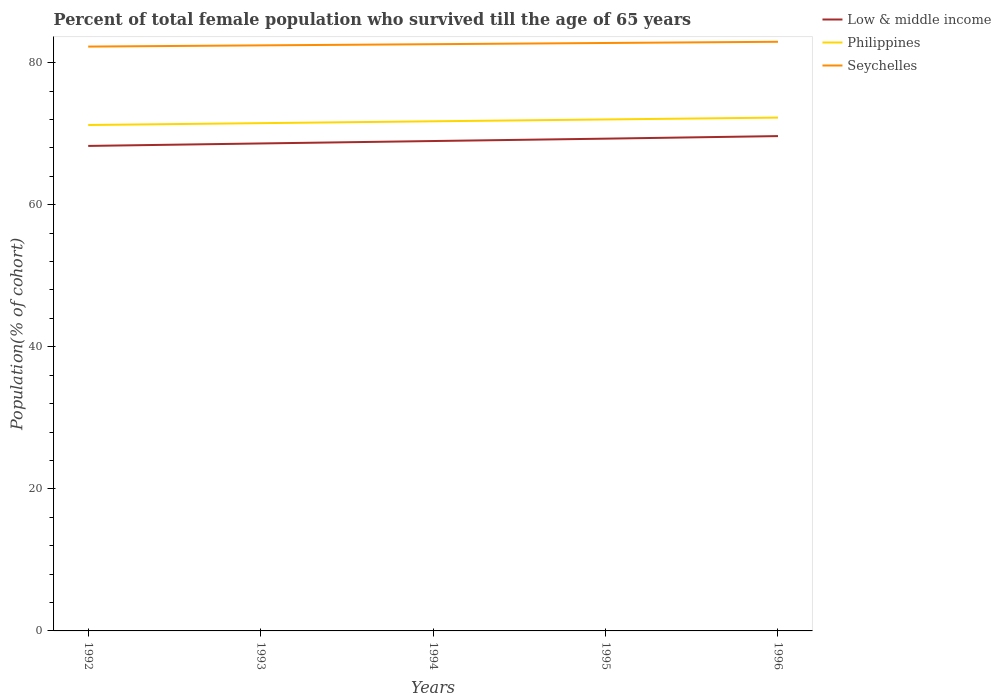Is the number of lines equal to the number of legend labels?
Offer a very short reply. Yes. Across all years, what is the maximum percentage of total female population who survived till the age of 65 years in Low & middle income?
Your answer should be compact. 68.28. What is the total percentage of total female population who survived till the age of 65 years in Low & middle income in the graph?
Your response must be concise. -0.36. What is the difference between the highest and the second highest percentage of total female population who survived till the age of 65 years in Low & middle income?
Ensure brevity in your answer.  1.38. Is the percentage of total female population who survived till the age of 65 years in Philippines strictly greater than the percentage of total female population who survived till the age of 65 years in Seychelles over the years?
Offer a very short reply. Yes. How many lines are there?
Keep it short and to the point. 3. How many years are there in the graph?
Offer a very short reply. 5. What is the difference between two consecutive major ticks on the Y-axis?
Offer a very short reply. 20. Are the values on the major ticks of Y-axis written in scientific E-notation?
Provide a short and direct response. No. Does the graph contain any zero values?
Your answer should be compact. No. Does the graph contain grids?
Provide a succinct answer. No. How many legend labels are there?
Your answer should be very brief. 3. What is the title of the graph?
Ensure brevity in your answer.  Percent of total female population who survived till the age of 65 years. What is the label or title of the Y-axis?
Your answer should be very brief. Population(% of cohort). What is the Population(% of cohort) of Low & middle income in 1992?
Your response must be concise. 68.28. What is the Population(% of cohort) in Philippines in 1992?
Offer a terse response. 71.23. What is the Population(% of cohort) in Seychelles in 1992?
Make the answer very short. 82.27. What is the Population(% of cohort) in Low & middle income in 1993?
Provide a succinct answer. 68.63. What is the Population(% of cohort) in Philippines in 1993?
Keep it short and to the point. 71.49. What is the Population(% of cohort) in Seychelles in 1993?
Your answer should be compact. 82.44. What is the Population(% of cohort) of Low & middle income in 1994?
Provide a succinct answer. 68.97. What is the Population(% of cohort) in Philippines in 1994?
Provide a short and direct response. 71.75. What is the Population(% of cohort) of Seychelles in 1994?
Your answer should be very brief. 82.6. What is the Population(% of cohort) in Low & middle income in 1995?
Provide a short and direct response. 69.3. What is the Population(% of cohort) in Philippines in 1995?
Keep it short and to the point. 72.01. What is the Population(% of cohort) of Seychelles in 1995?
Your response must be concise. 82.77. What is the Population(% of cohort) in Low & middle income in 1996?
Give a very brief answer. 69.66. What is the Population(% of cohort) of Philippines in 1996?
Provide a succinct answer. 72.27. What is the Population(% of cohort) of Seychelles in 1996?
Keep it short and to the point. 82.94. Across all years, what is the maximum Population(% of cohort) of Low & middle income?
Your response must be concise. 69.66. Across all years, what is the maximum Population(% of cohort) of Philippines?
Your answer should be very brief. 72.27. Across all years, what is the maximum Population(% of cohort) in Seychelles?
Offer a terse response. 82.94. Across all years, what is the minimum Population(% of cohort) in Low & middle income?
Your answer should be compact. 68.28. Across all years, what is the minimum Population(% of cohort) in Philippines?
Keep it short and to the point. 71.23. Across all years, what is the minimum Population(% of cohort) of Seychelles?
Offer a very short reply. 82.27. What is the total Population(% of cohort) in Low & middle income in the graph?
Your response must be concise. 344.84. What is the total Population(% of cohort) in Philippines in the graph?
Your answer should be compact. 358.73. What is the total Population(% of cohort) in Seychelles in the graph?
Your answer should be very brief. 413.02. What is the difference between the Population(% of cohort) of Low & middle income in 1992 and that in 1993?
Provide a succinct answer. -0.35. What is the difference between the Population(% of cohort) of Philippines in 1992 and that in 1993?
Give a very brief answer. -0.26. What is the difference between the Population(% of cohort) of Seychelles in 1992 and that in 1993?
Make the answer very short. -0.17. What is the difference between the Population(% of cohort) of Low & middle income in 1992 and that in 1994?
Provide a succinct answer. -0.69. What is the difference between the Population(% of cohort) in Philippines in 1992 and that in 1994?
Offer a terse response. -0.52. What is the difference between the Population(% of cohort) of Seychelles in 1992 and that in 1994?
Your response must be concise. -0.34. What is the difference between the Population(% of cohort) of Low & middle income in 1992 and that in 1995?
Your answer should be compact. -1.02. What is the difference between the Population(% of cohort) in Philippines in 1992 and that in 1995?
Offer a very short reply. -0.78. What is the difference between the Population(% of cohort) of Seychelles in 1992 and that in 1995?
Provide a succinct answer. -0.51. What is the difference between the Population(% of cohort) of Low & middle income in 1992 and that in 1996?
Your answer should be very brief. -1.38. What is the difference between the Population(% of cohort) in Philippines in 1992 and that in 1996?
Your answer should be very brief. -1.04. What is the difference between the Population(% of cohort) in Seychelles in 1992 and that in 1996?
Provide a succinct answer. -0.68. What is the difference between the Population(% of cohort) of Low & middle income in 1993 and that in 1994?
Keep it short and to the point. -0.34. What is the difference between the Population(% of cohort) in Philippines in 1993 and that in 1994?
Provide a short and direct response. -0.26. What is the difference between the Population(% of cohort) in Seychelles in 1993 and that in 1994?
Your response must be concise. -0.17. What is the difference between the Population(% of cohort) of Low & middle income in 1993 and that in 1995?
Offer a very short reply. -0.68. What is the difference between the Population(% of cohort) in Philippines in 1993 and that in 1995?
Give a very brief answer. -0.52. What is the difference between the Population(% of cohort) in Seychelles in 1993 and that in 1995?
Provide a succinct answer. -0.34. What is the difference between the Population(% of cohort) in Low & middle income in 1993 and that in 1996?
Your answer should be compact. -1.04. What is the difference between the Population(% of cohort) in Philippines in 1993 and that in 1996?
Your answer should be compact. -0.78. What is the difference between the Population(% of cohort) of Seychelles in 1993 and that in 1996?
Your response must be concise. -0.51. What is the difference between the Population(% of cohort) in Low & middle income in 1994 and that in 1995?
Offer a terse response. -0.33. What is the difference between the Population(% of cohort) of Philippines in 1994 and that in 1995?
Keep it short and to the point. -0.26. What is the difference between the Population(% of cohort) in Seychelles in 1994 and that in 1995?
Your answer should be very brief. -0.17. What is the difference between the Population(% of cohort) in Low & middle income in 1994 and that in 1996?
Offer a terse response. -0.7. What is the difference between the Population(% of cohort) in Philippines in 1994 and that in 1996?
Provide a succinct answer. -0.52. What is the difference between the Population(% of cohort) of Seychelles in 1994 and that in 1996?
Keep it short and to the point. -0.34. What is the difference between the Population(% of cohort) of Low & middle income in 1995 and that in 1996?
Offer a very short reply. -0.36. What is the difference between the Population(% of cohort) in Philippines in 1995 and that in 1996?
Make the answer very short. -0.26. What is the difference between the Population(% of cohort) of Seychelles in 1995 and that in 1996?
Your answer should be very brief. -0.17. What is the difference between the Population(% of cohort) in Low & middle income in 1992 and the Population(% of cohort) in Philippines in 1993?
Give a very brief answer. -3.21. What is the difference between the Population(% of cohort) in Low & middle income in 1992 and the Population(% of cohort) in Seychelles in 1993?
Provide a succinct answer. -14.15. What is the difference between the Population(% of cohort) in Philippines in 1992 and the Population(% of cohort) in Seychelles in 1993?
Provide a succinct answer. -11.21. What is the difference between the Population(% of cohort) of Low & middle income in 1992 and the Population(% of cohort) of Philippines in 1994?
Your answer should be very brief. -3.47. What is the difference between the Population(% of cohort) of Low & middle income in 1992 and the Population(% of cohort) of Seychelles in 1994?
Provide a short and direct response. -14.32. What is the difference between the Population(% of cohort) in Philippines in 1992 and the Population(% of cohort) in Seychelles in 1994?
Keep it short and to the point. -11.38. What is the difference between the Population(% of cohort) of Low & middle income in 1992 and the Population(% of cohort) of Philippines in 1995?
Give a very brief answer. -3.73. What is the difference between the Population(% of cohort) of Low & middle income in 1992 and the Population(% of cohort) of Seychelles in 1995?
Keep it short and to the point. -14.49. What is the difference between the Population(% of cohort) in Philippines in 1992 and the Population(% of cohort) in Seychelles in 1995?
Your response must be concise. -11.55. What is the difference between the Population(% of cohort) in Low & middle income in 1992 and the Population(% of cohort) in Philippines in 1996?
Offer a very short reply. -3.99. What is the difference between the Population(% of cohort) in Low & middle income in 1992 and the Population(% of cohort) in Seychelles in 1996?
Ensure brevity in your answer.  -14.66. What is the difference between the Population(% of cohort) of Philippines in 1992 and the Population(% of cohort) of Seychelles in 1996?
Ensure brevity in your answer.  -11.72. What is the difference between the Population(% of cohort) in Low & middle income in 1993 and the Population(% of cohort) in Philippines in 1994?
Provide a short and direct response. -3.12. What is the difference between the Population(% of cohort) of Low & middle income in 1993 and the Population(% of cohort) of Seychelles in 1994?
Offer a very short reply. -13.98. What is the difference between the Population(% of cohort) of Philippines in 1993 and the Population(% of cohort) of Seychelles in 1994?
Your answer should be compact. -11.12. What is the difference between the Population(% of cohort) of Low & middle income in 1993 and the Population(% of cohort) of Philippines in 1995?
Provide a succinct answer. -3.38. What is the difference between the Population(% of cohort) in Low & middle income in 1993 and the Population(% of cohort) in Seychelles in 1995?
Your answer should be very brief. -14.15. What is the difference between the Population(% of cohort) of Philippines in 1993 and the Population(% of cohort) of Seychelles in 1995?
Your answer should be compact. -11.29. What is the difference between the Population(% of cohort) of Low & middle income in 1993 and the Population(% of cohort) of Philippines in 1996?
Provide a short and direct response. -3.64. What is the difference between the Population(% of cohort) of Low & middle income in 1993 and the Population(% of cohort) of Seychelles in 1996?
Make the answer very short. -14.31. What is the difference between the Population(% of cohort) of Philippines in 1993 and the Population(% of cohort) of Seychelles in 1996?
Offer a very short reply. -11.46. What is the difference between the Population(% of cohort) in Low & middle income in 1994 and the Population(% of cohort) in Philippines in 1995?
Your answer should be very brief. -3.04. What is the difference between the Population(% of cohort) of Low & middle income in 1994 and the Population(% of cohort) of Seychelles in 1995?
Provide a succinct answer. -13.8. What is the difference between the Population(% of cohort) of Philippines in 1994 and the Population(% of cohort) of Seychelles in 1995?
Make the answer very short. -11.03. What is the difference between the Population(% of cohort) of Low & middle income in 1994 and the Population(% of cohort) of Philippines in 1996?
Offer a very short reply. -3.3. What is the difference between the Population(% of cohort) of Low & middle income in 1994 and the Population(% of cohort) of Seychelles in 1996?
Your answer should be very brief. -13.97. What is the difference between the Population(% of cohort) in Philippines in 1994 and the Population(% of cohort) in Seychelles in 1996?
Keep it short and to the point. -11.2. What is the difference between the Population(% of cohort) in Low & middle income in 1995 and the Population(% of cohort) in Philippines in 1996?
Make the answer very short. -2.96. What is the difference between the Population(% of cohort) of Low & middle income in 1995 and the Population(% of cohort) of Seychelles in 1996?
Offer a very short reply. -13.64. What is the difference between the Population(% of cohort) in Philippines in 1995 and the Population(% of cohort) in Seychelles in 1996?
Your answer should be compact. -10.94. What is the average Population(% of cohort) of Low & middle income per year?
Make the answer very short. 68.97. What is the average Population(% of cohort) in Philippines per year?
Provide a succinct answer. 71.75. What is the average Population(% of cohort) in Seychelles per year?
Your answer should be very brief. 82.6. In the year 1992, what is the difference between the Population(% of cohort) in Low & middle income and Population(% of cohort) in Philippines?
Provide a short and direct response. -2.95. In the year 1992, what is the difference between the Population(% of cohort) in Low & middle income and Population(% of cohort) in Seychelles?
Your answer should be compact. -13.99. In the year 1992, what is the difference between the Population(% of cohort) of Philippines and Population(% of cohort) of Seychelles?
Your response must be concise. -11.04. In the year 1993, what is the difference between the Population(% of cohort) in Low & middle income and Population(% of cohort) in Philippines?
Your response must be concise. -2.86. In the year 1993, what is the difference between the Population(% of cohort) in Low & middle income and Population(% of cohort) in Seychelles?
Keep it short and to the point. -13.81. In the year 1993, what is the difference between the Population(% of cohort) of Philippines and Population(% of cohort) of Seychelles?
Give a very brief answer. -10.95. In the year 1994, what is the difference between the Population(% of cohort) of Low & middle income and Population(% of cohort) of Philippines?
Your answer should be compact. -2.78. In the year 1994, what is the difference between the Population(% of cohort) of Low & middle income and Population(% of cohort) of Seychelles?
Offer a terse response. -13.64. In the year 1994, what is the difference between the Population(% of cohort) of Philippines and Population(% of cohort) of Seychelles?
Offer a terse response. -10.86. In the year 1995, what is the difference between the Population(% of cohort) of Low & middle income and Population(% of cohort) of Philippines?
Your answer should be very brief. -2.7. In the year 1995, what is the difference between the Population(% of cohort) of Low & middle income and Population(% of cohort) of Seychelles?
Your answer should be compact. -13.47. In the year 1995, what is the difference between the Population(% of cohort) of Philippines and Population(% of cohort) of Seychelles?
Offer a terse response. -10.77. In the year 1996, what is the difference between the Population(% of cohort) in Low & middle income and Population(% of cohort) in Philippines?
Your answer should be very brief. -2.6. In the year 1996, what is the difference between the Population(% of cohort) in Low & middle income and Population(% of cohort) in Seychelles?
Make the answer very short. -13.28. In the year 1996, what is the difference between the Population(% of cohort) in Philippines and Population(% of cohort) in Seychelles?
Your answer should be very brief. -10.67. What is the ratio of the Population(% of cohort) in Low & middle income in 1992 to that in 1993?
Provide a succinct answer. 0.99. What is the ratio of the Population(% of cohort) in Philippines in 1992 to that in 1993?
Keep it short and to the point. 1. What is the ratio of the Population(% of cohort) of Seychelles in 1992 to that in 1993?
Ensure brevity in your answer.  1. What is the ratio of the Population(% of cohort) of Low & middle income in 1992 to that in 1995?
Offer a very short reply. 0.99. What is the ratio of the Population(% of cohort) of Low & middle income in 1992 to that in 1996?
Make the answer very short. 0.98. What is the ratio of the Population(% of cohort) of Philippines in 1992 to that in 1996?
Give a very brief answer. 0.99. What is the ratio of the Population(% of cohort) in Philippines in 1993 to that in 1994?
Ensure brevity in your answer.  1. What is the ratio of the Population(% of cohort) of Seychelles in 1993 to that in 1994?
Your answer should be compact. 1. What is the ratio of the Population(% of cohort) in Low & middle income in 1993 to that in 1995?
Offer a very short reply. 0.99. What is the ratio of the Population(% of cohort) in Philippines in 1993 to that in 1995?
Provide a succinct answer. 0.99. What is the ratio of the Population(% of cohort) in Low & middle income in 1993 to that in 1996?
Your response must be concise. 0.99. What is the ratio of the Population(% of cohort) in Philippines in 1993 to that in 1996?
Make the answer very short. 0.99. What is the ratio of the Population(% of cohort) in Seychelles in 1993 to that in 1996?
Provide a succinct answer. 0.99. What is the ratio of the Population(% of cohort) of Low & middle income in 1994 to that in 1995?
Your answer should be very brief. 1. What is the ratio of the Population(% of cohort) of Philippines in 1994 to that in 1995?
Offer a very short reply. 1. What is the ratio of the Population(% of cohort) in Low & middle income in 1994 to that in 1996?
Your answer should be very brief. 0.99. What is the ratio of the Population(% of cohort) in Seychelles in 1994 to that in 1996?
Keep it short and to the point. 1. What is the difference between the highest and the second highest Population(% of cohort) of Low & middle income?
Offer a very short reply. 0.36. What is the difference between the highest and the second highest Population(% of cohort) in Philippines?
Your answer should be compact. 0.26. What is the difference between the highest and the second highest Population(% of cohort) of Seychelles?
Provide a short and direct response. 0.17. What is the difference between the highest and the lowest Population(% of cohort) of Low & middle income?
Your answer should be very brief. 1.38. What is the difference between the highest and the lowest Population(% of cohort) of Philippines?
Your answer should be very brief. 1.04. What is the difference between the highest and the lowest Population(% of cohort) in Seychelles?
Give a very brief answer. 0.68. 